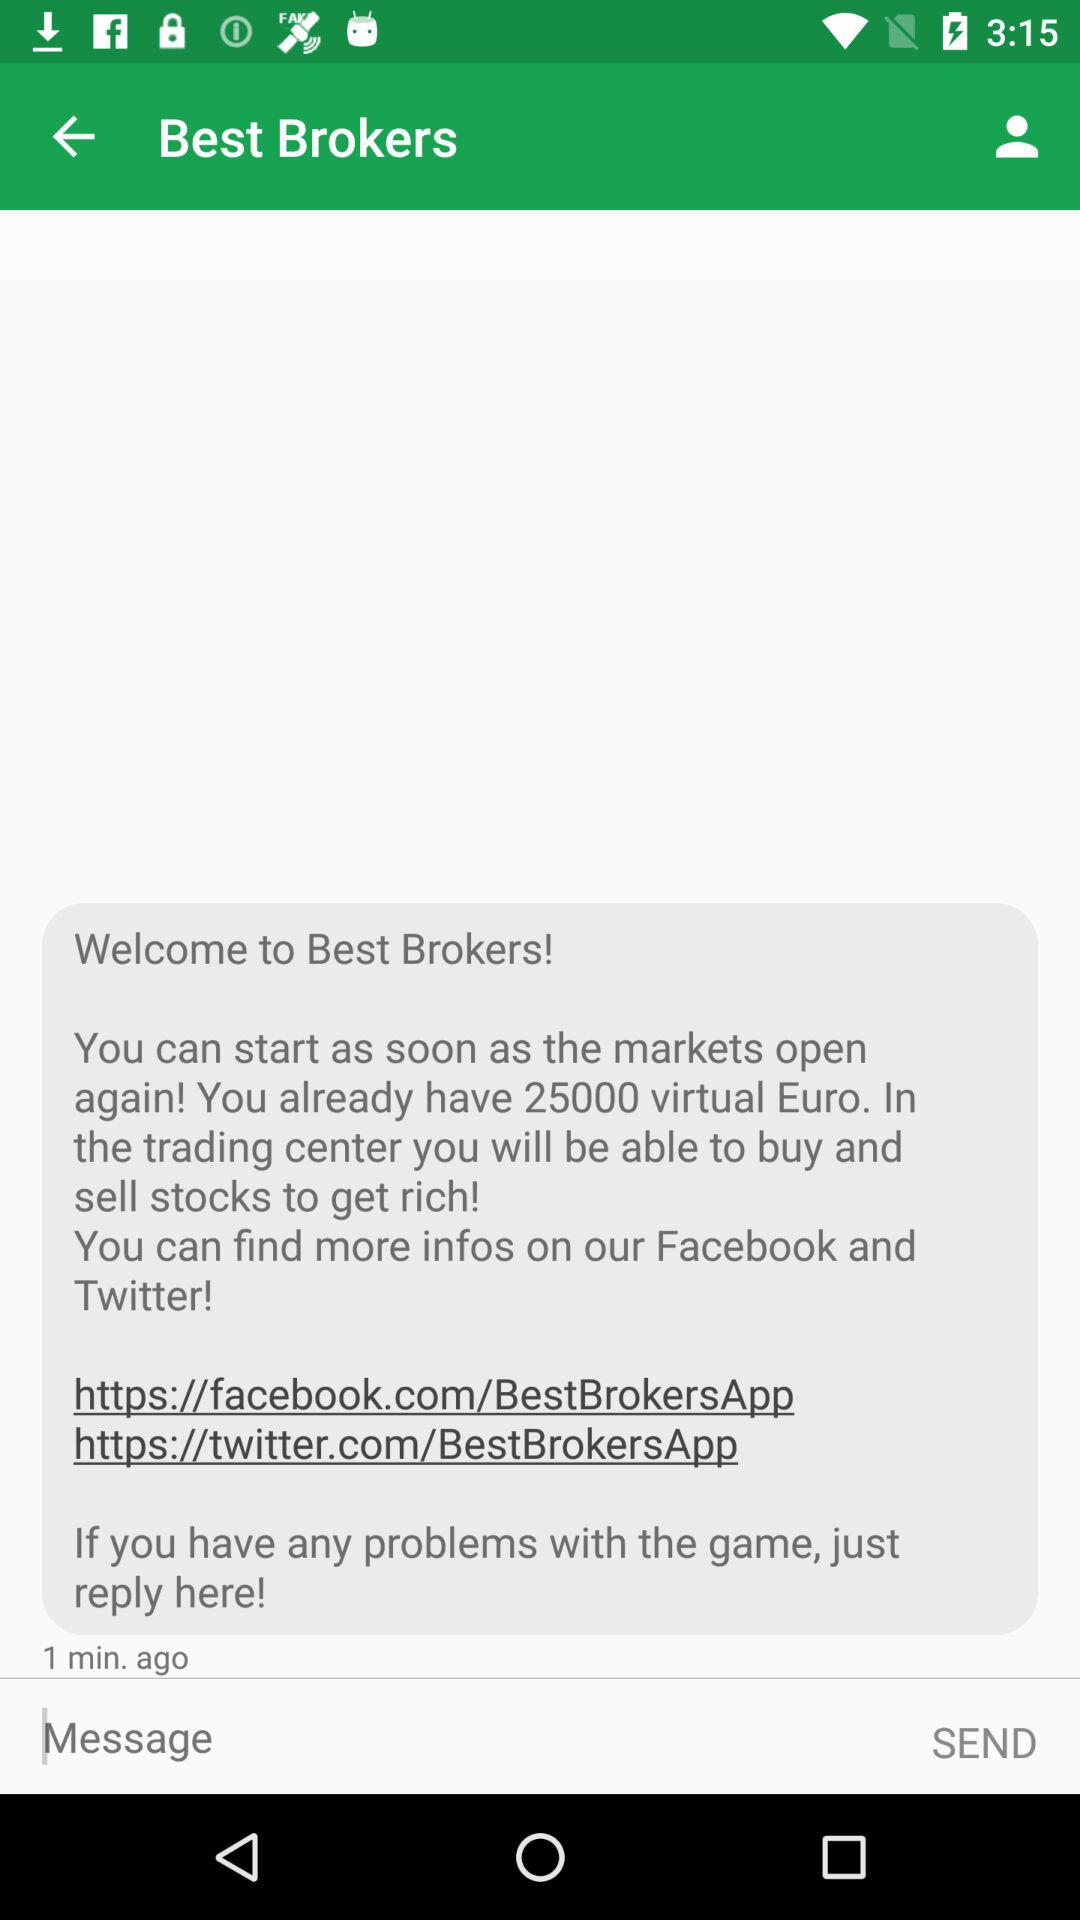How many minutes ago was this message received? This message was received 1 minute ago. 